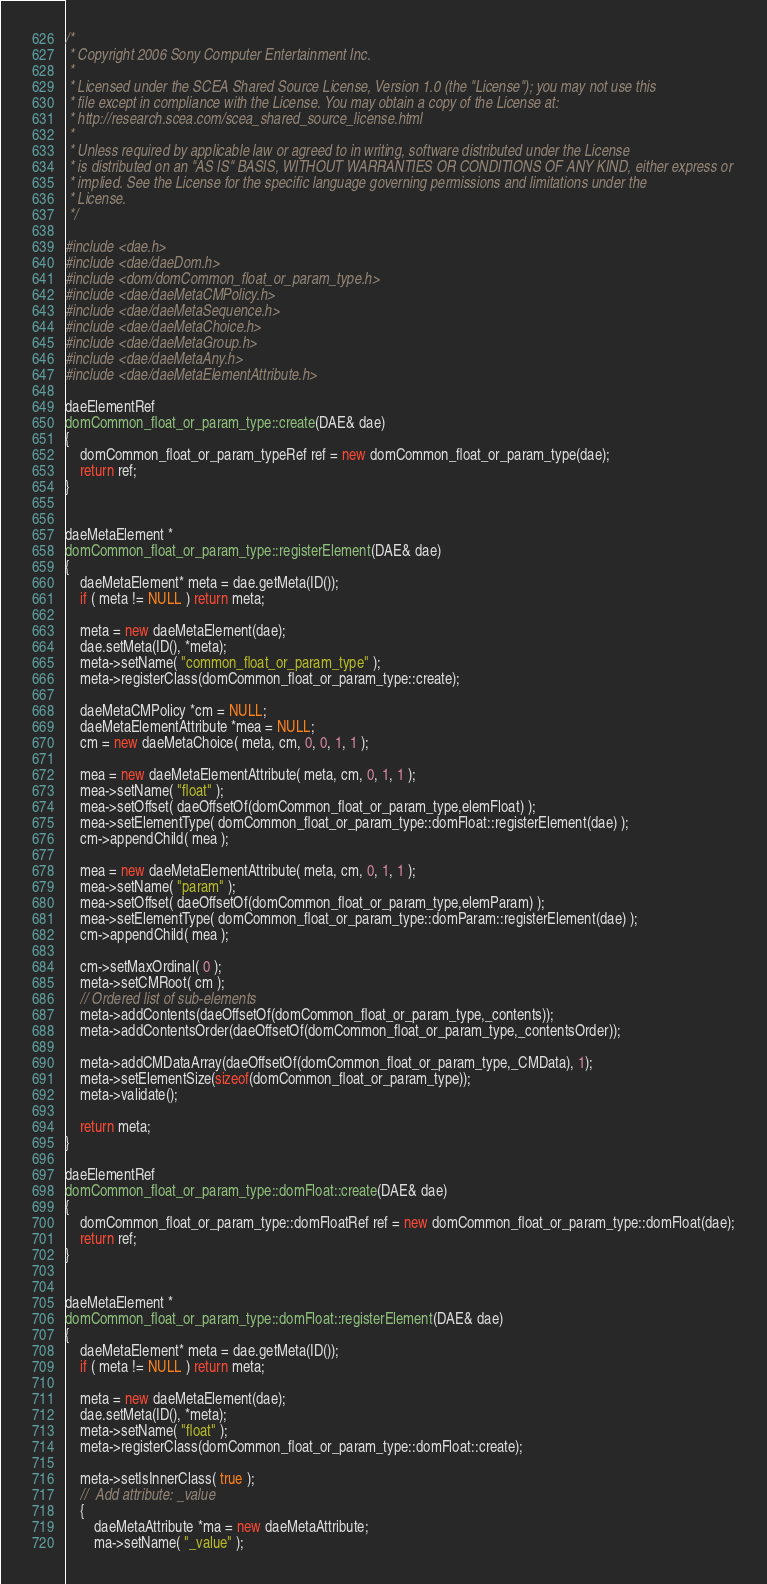Convert code to text. <code><loc_0><loc_0><loc_500><loc_500><_C++_>/*
 * Copyright 2006 Sony Computer Entertainment Inc.
 *
 * Licensed under the SCEA Shared Source License, Version 1.0 (the "License"); you may not use this
 * file except in compliance with the License. You may obtain a copy of the License at:
 * http://research.scea.com/scea_shared_source_license.html
 *
 * Unless required by applicable law or agreed to in writing, software distributed under the License
 * is distributed on an "AS IS" BASIS, WITHOUT WARRANTIES OR CONDITIONS OF ANY KIND, either express or
 * implied. See the License for the specific language governing permissions and limitations under the
 * License.
 */

#include <dae.h>
#include <dae/daeDom.h>
#include <dom/domCommon_float_or_param_type.h>
#include <dae/daeMetaCMPolicy.h>
#include <dae/daeMetaSequence.h>
#include <dae/daeMetaChoice.h>
#include <dae/daeMetaGroup.h>
#include <dae/daeMetaAny.h>
#include <dae/daeMetaElementAttribute.h>

daeElementRef
domCommon_float_or_param_type::create(DAE& dae)
{
	domCommon_float_or_param_typeRef ref = new domCommon_float_or_param_type(dae);
	return ref;
}


daeMetaElement *
domCommon_float_or_param_type::registerElement(DAE& dae)
{
	daeMetaElement* meta = dae.getMeta(ID());
	if ( meta != NULL ) return meta;

	meta = new daeMetaElement(dae);
	dae.setMeta(ID(), *meta);
	meta->setName( "common_float_or_param_type" );
	meta->registerClass(domCommon_float_or_param_type::create);

	daeMetaCMPolicy *cm = NULL;
	daeMetaElementAttribute *mea = NULL;
	cm = new daeMetaChoice( meta, cm, 0, 0, 1, 1 );

	mea = new daeMetaElementAttribute( meta, cm, 0, 1, 1 );
	mea->setName( "float" );
	mea->setOffset( daeOffsetOf(domCommon_float_or_param_type,elemFloat) );
	mea->setElementType( domCommon_float_or_param_type::domFloat::registerElement(dae) );
	cm->appendChild( mea );

	mea = new daeMetaElementAttribute( meta, cm, 0, 1, 1 );
	mea->setName( "param" );
	mea->setOffset( daeOffsetOf(domCommon_float_or_param_type,elemParam) );
	mea->setElementType( domCommon_float_or_param_type::domParam::registerElement(dae) );
	cm->appendChild( mea );

	cm->setMaxOrdinal( 0 );
	meta->setCMRoot( cm );	
	// Ordered list of sub-elements
	meta->addContents(daeOffsetOf(domCommon_float_or_param_type,_contents));
	meta->addContentsOrder(daeOffsetOf(domCommon_float_or_param_type,_contentsOrder));

	meta->addCMDataArray(daeOffsetOf(domCommon_float_or_param_type,_CMData), 1);
	meta->setElementSize(sizeof(domCommon_float_or_param_type));
	meta->validate();

	return meta;
}

daeElementRef
domCommon_float_or_param_type::domFloat::create(DAE& dae)
{
	domCommon_float_or_param_type::domFloatRef ref = new domCommon_float_or_param_type::domFloat(dae);
	return ref;
}


daeMetaElement *
domCommon_float_or_param_type::domFloat::registerElement(DAE& dae)
{
	daeMetaElement* meta = dae.getMeta(ID());
	if ( meta != NULL ) return meta;

	meta = new daeMetaElement(dae);
	dae.setMeta(ID(), *meta);
	meta->setName( "float" );
	meta->registerClass(domCommon_float_or_param_type::domFloat::create);

	meta->setIsInnerClass( true );
	//	Add attribute: _value
	{
		daeMetaAttribute *ma = new daeMetaAttribute;
		ma->setName( "_value" );</code> 